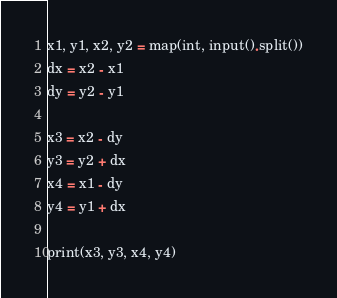Convert code to text. <code><loc_0><loc_0><loc_500><loc_500><_Python_>x1, y1, x2, y2 = map(int, input().split())
dx = x2 - x1
dy = y2 - y1

x3 = x2 - dy
y3 = y2 + dx
x4 = x1 - dy
y4 = y1 + dx

print(x3, y3, x4, y4)</code> 